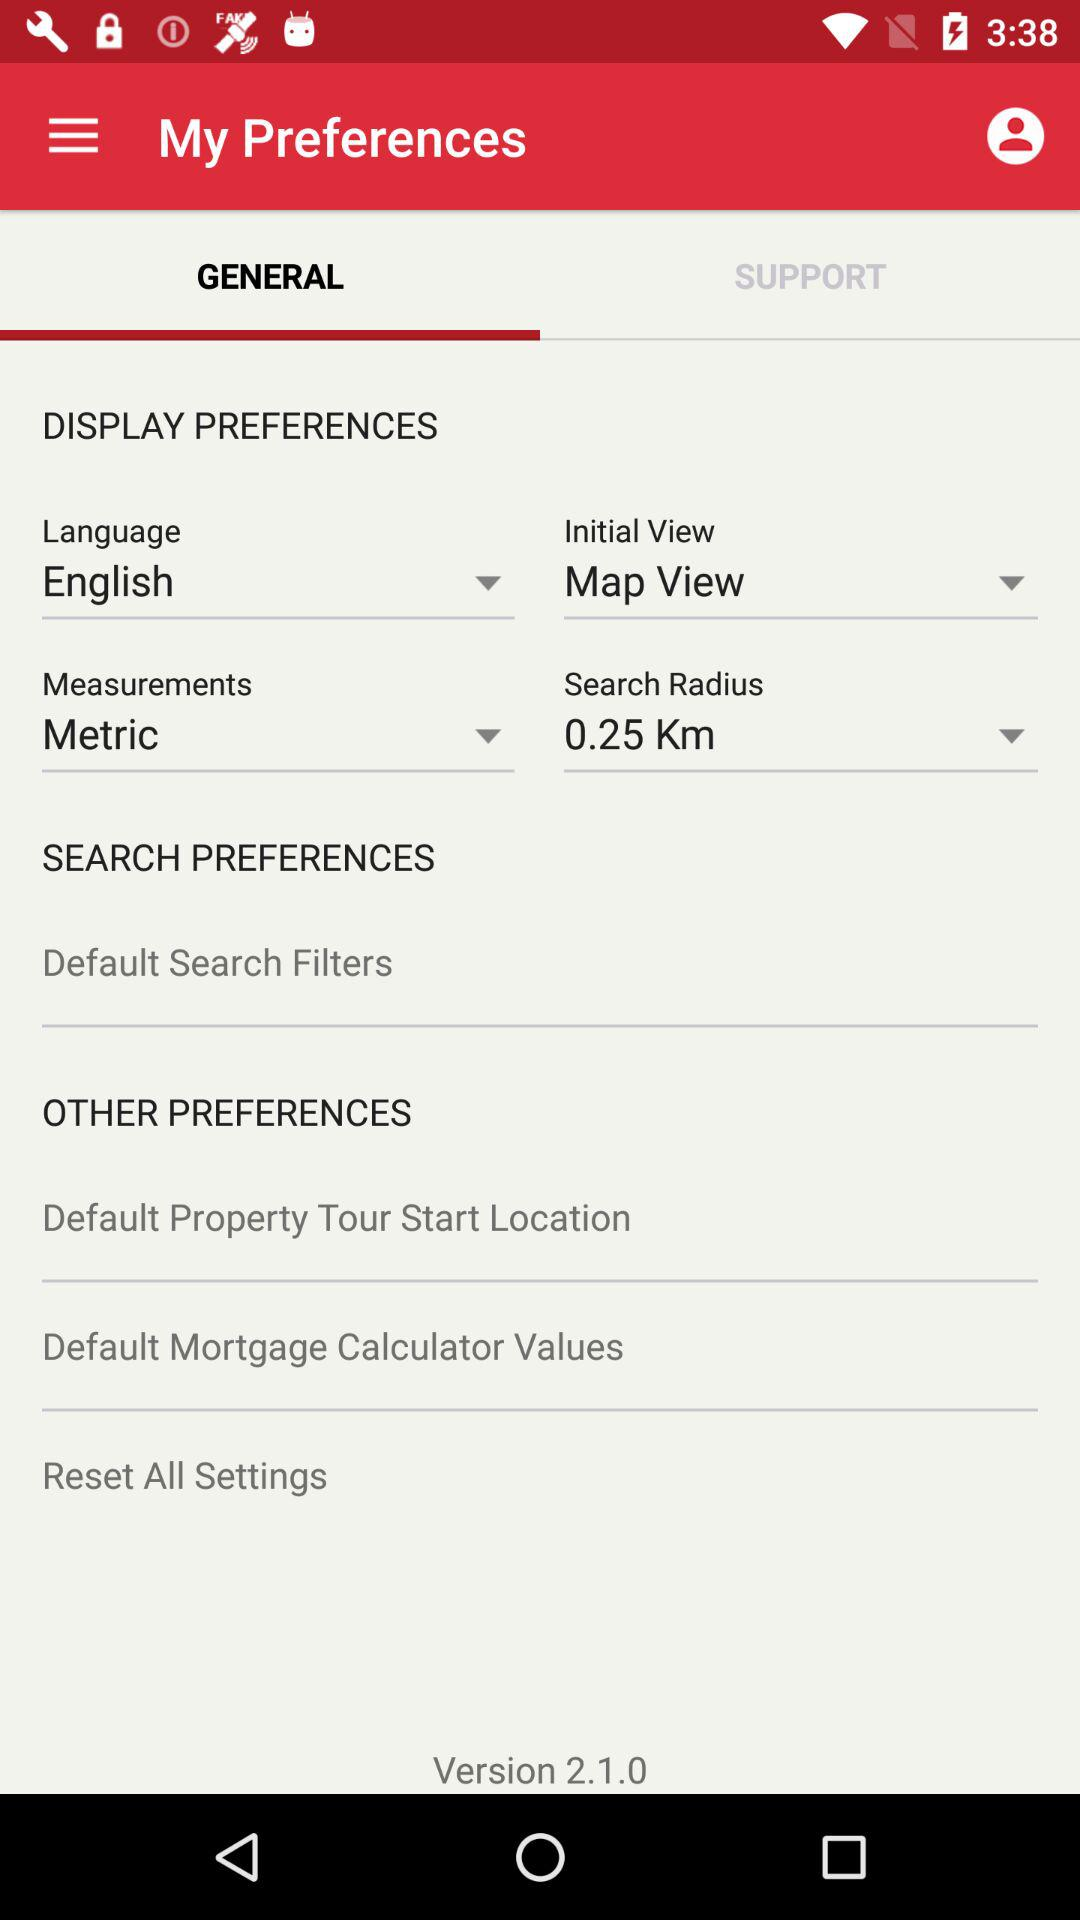Which tab is selected? The selected tab is "GENERAL". 